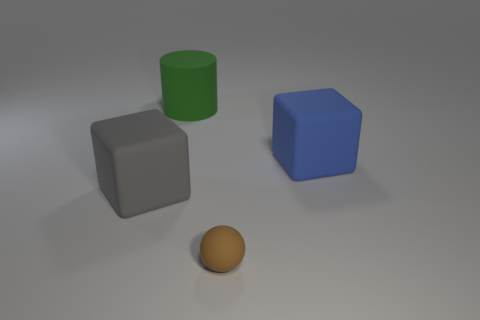If this scene were used in an educational context, what concepts could it help illustrate? This scene could be utilized to teach a variety of educational concepts such as basic geometric shapes like cylinders, spheres, and cubes. It could also illustrate principles of light and shadow, the concepts of color and textures in objects (matte vs. rubber), and basic spatial relationships such as 'to the left of,' 'larger than,' or 'in front of.' 